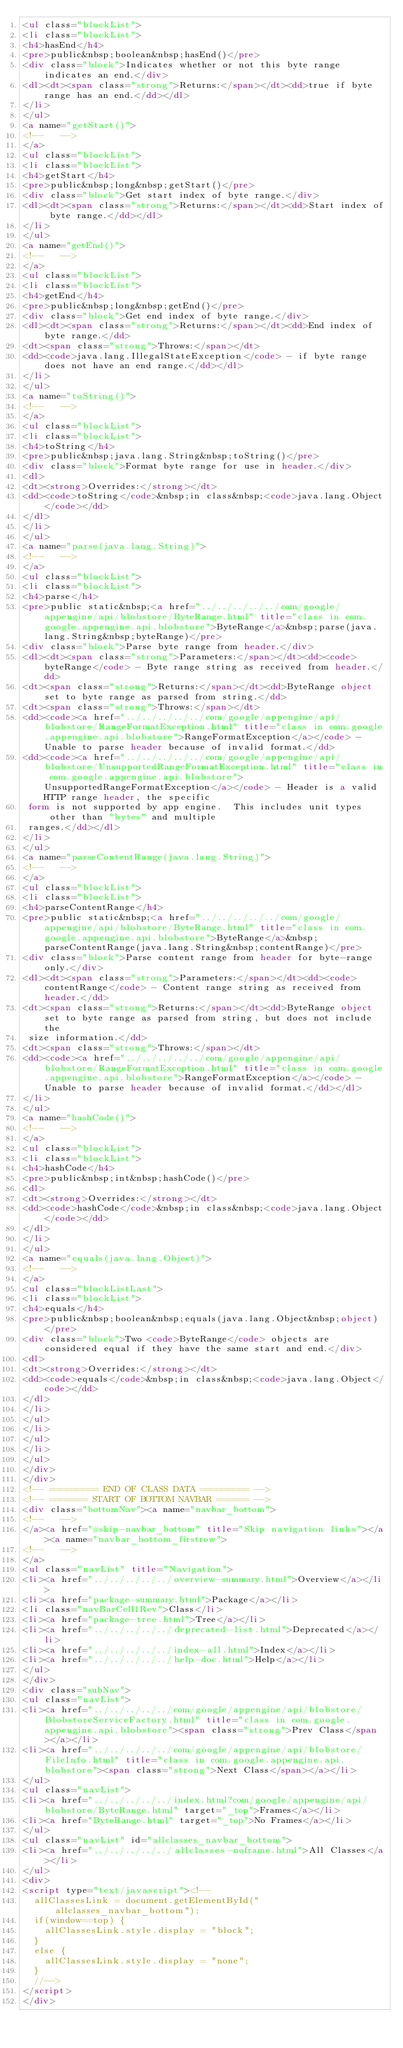<code> <loc_0><loc_0><loc_500><loc_500><_HTML_><ul class="blockList">
<li class="blockList">
<h4>hasEnd</h4>
<pre>public&nbsp;boolean&nbsp;hasEnd()</pre>
<div class="block">Indicates whether or not this byte range indicates an end.</div>
<dl><dt><span class="strong">Returns:</span></dt><dd>true if byte range has an end.</dd></dl>
</li>
</ul>
<a name="getStart()">
<!--   -->
</a>
<ul class="blockList">
<li class="blockList">
<h4>getStart</h4>
<pre>public&nbsp;long&nbsp;getStart()</pre>
<div class="block">Get start index of byte range.</div>
<dl><dt><span class="strong">Returns:</span></dt><dd>Start index of byte range.</dd></dl>
</li>
</ul>
<a name="getEnd()">
<!--   -->
</a>
<ul class="blockList">
<li class="blockList">
<h4>getEnd</h4>
<pre>public&nbsp;long&nbsp;getEnd()</pre>
<div class="block">Get end index of byte range.</div>
<dl><dt><span class="strong">Returns:</span></dt><dd>End index of byte range.</dd>
<dt><span class="strong">Throws:</span></dt>
<dd><code>java.lang.IllegalStateException</code> - if byte range does not have an end range.</dd></dl>
</li>
</ul>
<a name="toString()">
<!--   -->
</a>
<ul class="blockList">
<li class="blockList">
<h4>toString</h4>
<pre>public&nbsp;java.lang.String&nbsp;toString()</pre>
<div class="block">Format byte range for use in header.</div>
<dl>
<dt><strong>Overrides:</strong></dt>
<dd><code>toString</code>&nbsp;in class&nbsp;<code>java.lang.Object</code></dd>
</dl>
</li>
</ul>
<a name="parse(java.lang.String)">
<!--   -->
</a>
<ul class="blockList">
<li class="blockList">
<h4>parse</h4>
<pre>public static&nbsp;<a href="../../../../../com/google/appengine/api/blobstore/ByteRange.html" title="class in com.google.appengine.api.blobstore">ByteRange</a>&nbsp;parse(java.lang.String&nbsp;byteRange)</pre>
<div class="block">Parse byte range from header.</div>
<dl><dt><span class="strong">Parameters:</span></dt><dd><code>byteRange</code> - Byte range string as received from header.</dd>
<dt><span class="strong">Returns:</span></dt><dd>ByteRange object set to byte range as parsed from string.</dd>
<dt><span class="strong">Throws:</span></dt>
<dd><code><a href="../../../../../com/google/appengine/api/blobstore/RangeFormatException.html" title="class in com.google.appengine.api.blobstore">RangeFormatException</a></code> - Unable to parse header because of invalid format.</dd>
<dd><code><a href="../../../../../com/google/appengine/api/blobstore/UnsupportedRangeFormatException.html" title="class in com.google.appengine.api.blobstore">UnsupportedRangeFormatException</a></code> - Header is a valid HTTP range header, the specific
 form is not supported by app engine.  This includes unit types other than "bytes" and multiple
 ranges.</dd></dl>
</li>
</ul>
<a name="parseContentRange(java.lang.String)">
<!--   -->
</a>
<ul class="blockList">
<li class="blockList">
<h4>parseContentRange</h4>
<pre>public static&nbsp;<a href="../../../../../com/google/appengine/api/blobstore/ByteRange.html" title="class in com.google.appengine.api.blobstore">ByteRange</a>&nbsp;parseContentRange(java.lang.String&nbsp;contentRange)</pre>
<div class="block">Parse content range from header for byte-range only.</div>
<dl><dt><span class="strong">Parameters:</span></dt><dd><code>contentRange</code> - Content range string as received from header.</dd>
<dt><span class="strong">Returns:</span></dt><dd>ByteRange object set to byte range as parsed from string, but does not include the
 size information.</dd>
<dt><span class="strong">Throws:</span></dt>
<dd><code><a href="../../../../../com/google/appengine/api/blobstore/RangeFormatException.html" title="class in com.google.appengine.api.blobstore">RangeFormatException</a></code> - Unable to parse header because of invalid format.</dd></dl>
</li>
</ul>
<a name="hashCode()">
<!--   -->
</a>
<ul class="blockList">
<li class="blockList">
<h4>hashCode</h4>
<pre>public&nbsp;int&nbsp;hashCode()</pre>
<dl>
<dt><strong>Overrides:</strong></dt>
<dd><code>hashCode</code>&nbsp;in class&nbsp;<code>java.lang.Object</code></dd>
</dl>
</li>
</ul>
<a name="equals(java.lang.Object)">
<!--   -->
</a>
<ul class="blockListLast">
<li class="blockList">
<h4>equals</h4>
<pre>public&nbsp;boolean&nbsp;equals(java.lang.Object&nbsp;object)</pre>
<div class="block">Two <code>ByteRange</code> objects are considered equal if they have the same start and end.</div>
<dl>
<dt><strong>Overrides:</strong></dt>
<dd><code>equals</code>&nbsp;in class&nbsp;<code>java.lang.Object</code></dd>
</dl>
</li>
</ul>
</li>
</ul>
</li>
</ul>
</div>
</div>
<!-- ========= END OF CLASS DATA ========= -->
<!-- ======= START OF BOTTOM NAVBAR ====== -->
<div class="bottomNav"><a name="navbar_bottom">
<!--   -->
</a><a href="#skip-navbar_bottom" title="Skip navigation links"></a><a name="navbar_bottom_firstrow">
<!--   -->
</a>
<ul class="navList" title="Navigation">
<li><a href="../../../../../overview-summary.html">Overview</a></li>
<li><a href="package-summary.html">Package</a></li>
<li class="navBarCell1Rev">Class</li>
<li><a href="package-tree.html">Tree</a></li>
<li><a href="../../../../../deprecated-list.html">Deprecated</a></li>
<li><a href="../../../../../index-all.html">Index</a></li>
<li><a href="../../../../../help-doc.html">Help</a></li>
</ul>
</div>
<div class="subNav">
<ul class="navList">
<li><a href="../../../../../com/google/appengine/api/blobstore/BlobstoreServiceFactory.html" title="class in com.google.appengine.api.blobstore"><span class="strong">Prev Class</span></a></li>
<li><a href="../../../../../com/google/appengine/api/blobstore/FileInfo.html" title="class in com.google.appengine.api.blobstore"><span class="strong">Next Class</span></a></li>
</ul>
<ul class="navList">
<li><a href="../../../../../index.html?com/google/appengine/api/blobstore/ByteRange.html" target="_top">Frames</a></li>
<li><a href="ByteRange.html" target="_top">No Frames</a></li>
</ul>
<ul class="navList" id="allclasses_navbar_bottom">
<li><a href="../../../../../allclasses-noframe.html">All Classes</a></li>
</ul>
<div>
<script type="text/javascript"><!--
  allClassesLink = document.getElementById("allclasses_navbar_bottom");
  if(window==top) {
    allClassesLink.style.display = "block";
  }
  else {
    allClassesLink.style.display = "none";
  }
  //-->
</script>
</div></code> 